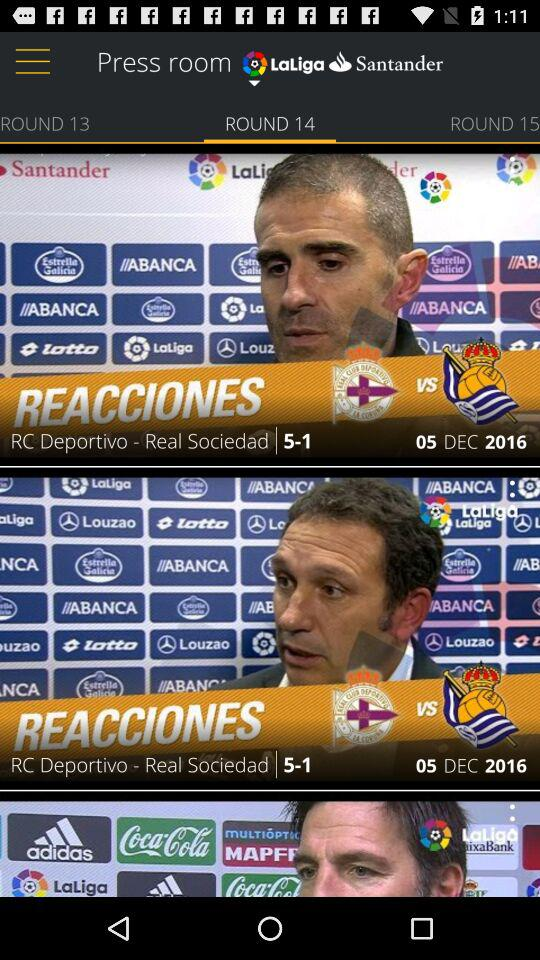How many teams are playing in the match?
Answer the question using a single word or phrase. 2 